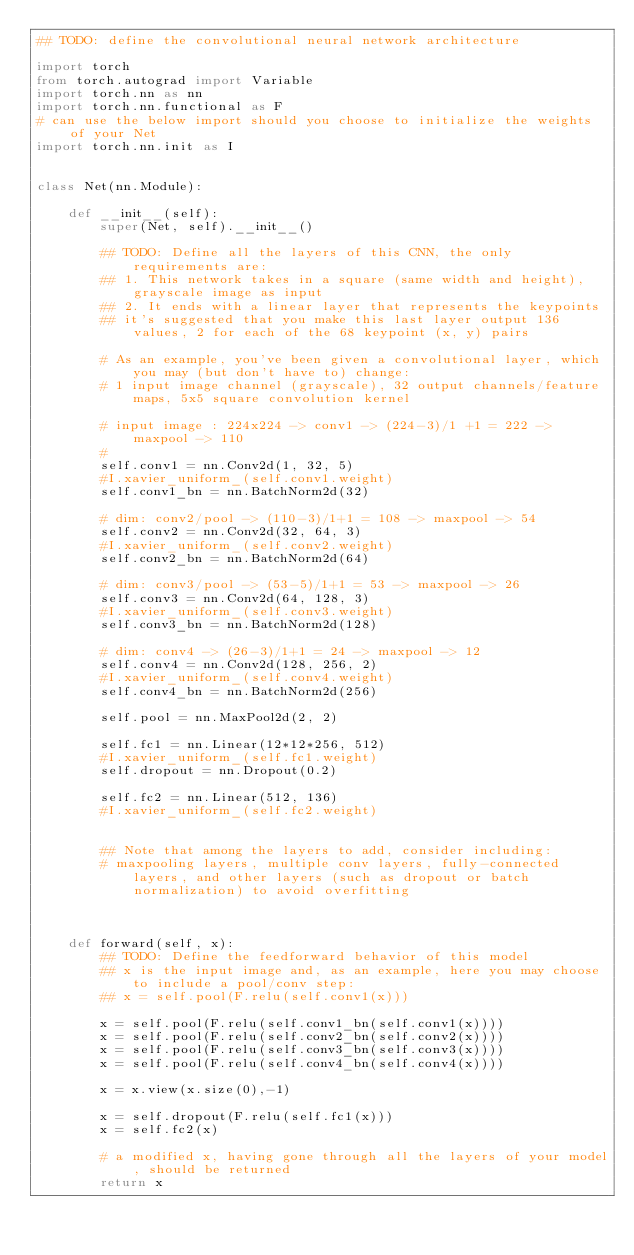Convert code to text. <code><loc_0><loc_0><loc_500><loc_500><_Python_>## TODO: define the convolutional neural network architecture

import torch
from torch.autograd import Variable
import torch.nn as nn
import torch.nn.functional as F
# can use the below import should you choose to initialize the weights of your Net
import torch.nn.init as I


class Net(nn.Module):

    def __init__(self):
        super(Net, self).__init__()
        
        ## TODO: Define all the layers of this CNN, the only requirements are:
        ## 1. This network takes in a square (same width and height), grayscale image as input
        ## 2. It ends with a linear layer that represents the keypoints
        ## it's suggested that you make this last layer output 136 values, 2 for each of the 68 keypoint (x, y) pairs
        
        # As an example, you've been given a convolutional layer, which you may (but don't have to) change:
        # 1 input image channel (grayscale), 32 output channels/feature maps, 5x5 square convolution kernel
        
        # input image : 224x224 -> conv1 -> (224-3)/1 +1 = 222 -> maxpool -> 110
        # 
        self.conv1 = nn.Conv2d(1, 32, 5) 
        #I.xavier_uniform_(self.conv1.weight)
        self.conv1_bn = nn.BatchNorm2d(32)
        
        # dim: conv2/pool -> (110-3)/1+1 = 108 -> maxpool -> 54
        self.conv2 = nn.Conv2d(32, 64, 3)
        #I.xavier_uniform_(self.conv2.weight)
        self.conv2_bn = nn.BatchNorm2d(64)
        
        # dim: conv3/pool -> (53-5)/1+1 = 53 -> maxpool -> 26
        self.conv3 = nn.Conv2d(64, 128, 3)
        #I.xavier_uniform_(self.conv3.weight)
        self.conv3_bn = nn.BatchNorm2d(128)
        
        # dim: conv4 -> (26-3)/1+1 = 24 -> maxpool -> 12
        self.conv4 = nn.Conv2d(128, 256, 2)
        #I.xavier_uniform_(self.conv4.weight)
        self.conv4_bn = nn.BatchNorm2d(256)
        
        self.pool = nn.MaxPool2d(2, 2)
        
        self.fc1 = nn.Linear(12*12*256, 512)
        #I.xavier_uniform_(self.fc1.weight)
        self.dropout = nn.Dropout(0.2)
        
        self.fc2 = nn.Linear(512, 136)
        #I.xavier_uniform_(self.fc2.weight)
        
        
        ## Note that among the layers to add, consider including:
        # maxpooling layers, multiple conv layers, fully-connected layers, and other layers (such as dropout or batch normalization) to avoid overfitting
        

        
    def forward(self, x):
        ## TODO: Define the feedforward behavior of this model
        ## x is the input image and, as an example, here you may choose to include a pool/conv step:
        ## x = self.pool(F.relu(self.conv1(x)))
        
        x = self.pool(F.relu(self.conv1_bn(self.conv1(x))))
        x = self.pool(F.relu(self.conv2_bn(self.conv2(x))))
        x = self.pool(F.relu(self.conv3_bn(self.conv3(x))))
        x = self.pool(F.relu(self.conv4_bn(self.conv4(x))))
        
        x = x.view(x.size(0),-1)
        
        x = self.dropout(F.relu(self.fc1(x)))
        x = self.fc2(x)
        
        # a modified x, having gone through all the layers of your model, should be returned
        return x</code> 